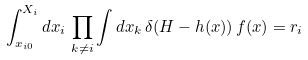<formula> <loc_0><loc_0><loc_500><loc_500>\int ^ { X _ { i } } _ { x _ { i 0 } } d x _ { i } \, \prod _ { k \neq i } \int d x _ { k } \, \delta ( H - h ( x ) ) \, f ( x ) = r _ { i }</formula> 